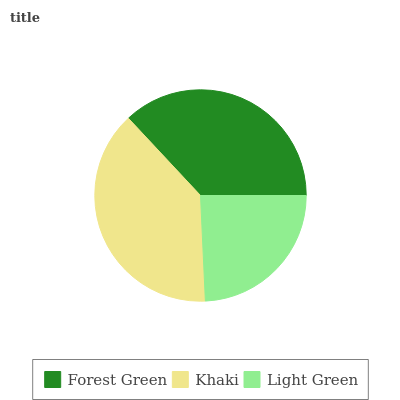Is Light Green the minimum?
Answer yes or no. Yes. Is Khaki the maximum?
Answer yes or no. Yes. Is Khaki the minimum?
Answer yes or no. No. Is Light Green the maximum?
Answer yes or no. No. Is Khaki greater than Light Green?
Answer yes or no. Yes. Is Light Green less than Khaki?
Answer yes or no. Yes. Is Light Green greater than Khaki?
Answer yes or no. No. Is Khaki less than Light Green?
Answer yes or no. No. Is Forest Green the high median?
Answer yes or no. Yes. Is Forest Green the low median?
Answer yes or no. Yes. Is Light Green the high median?
Answer yes or no. No. Is Light Green the low median?
Answer yes or no. No. 